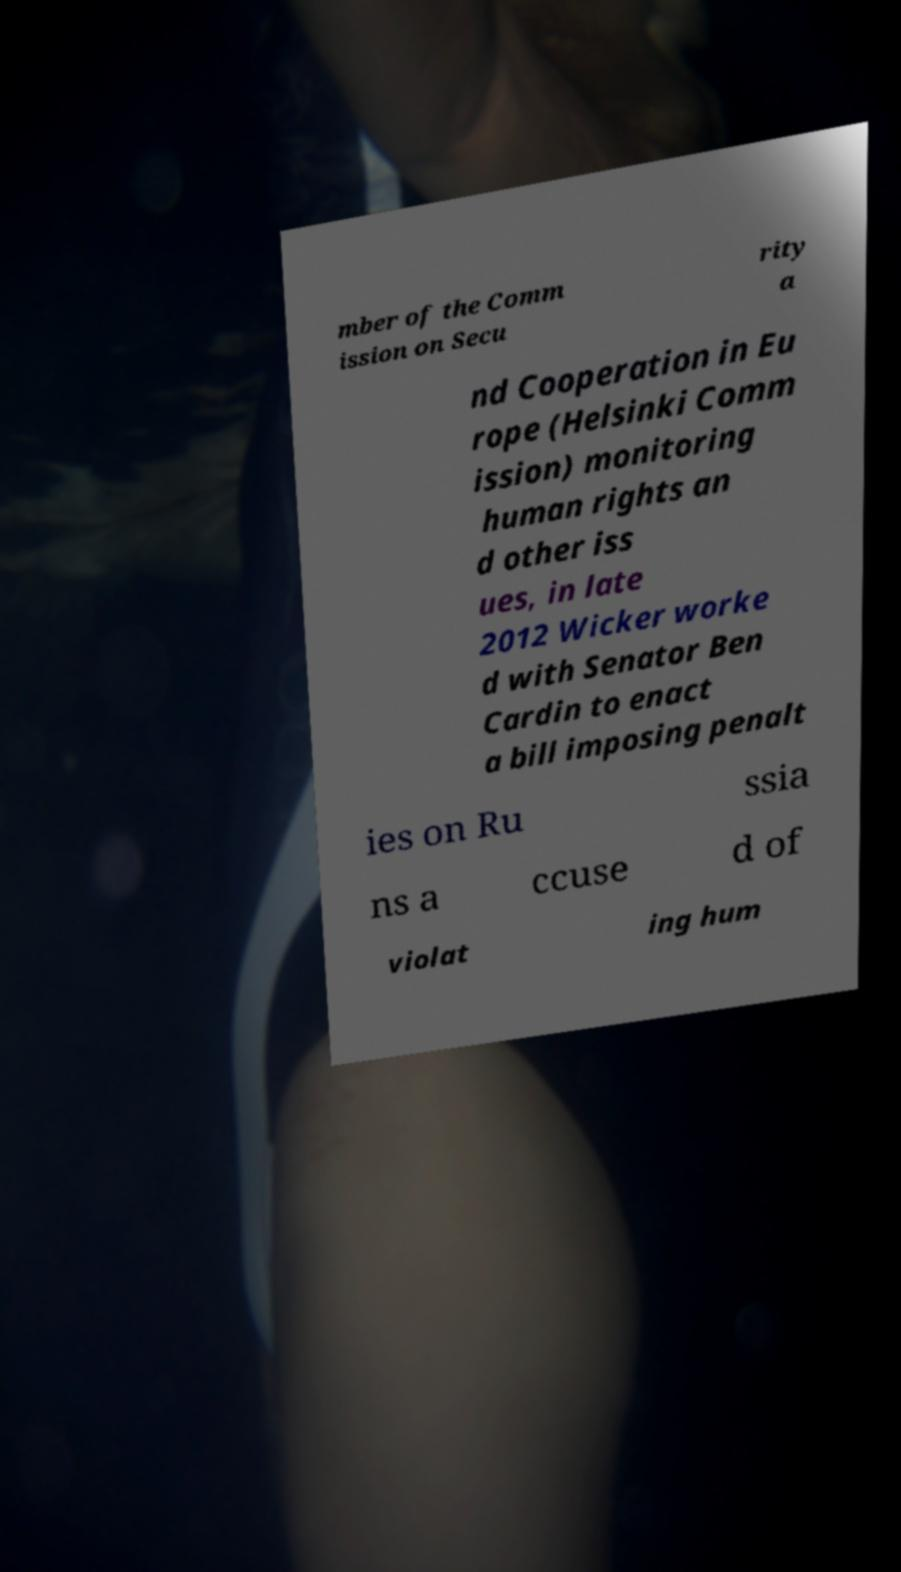Can you read and provide the text displayed in the image?This photo seems to have some interesting text. Can you extract and type it out for me? mber of the Comm ission on Secu rity a nd Cooperation in Eu rope (Helsinki Comm ission) monitoring human rights an d other iss ues, in late 2012 Wicker worke d with Senator Ben Cardin to enact a bill imposing penalt ies on Ru ssia ns a ccuse d of violat ing hum 